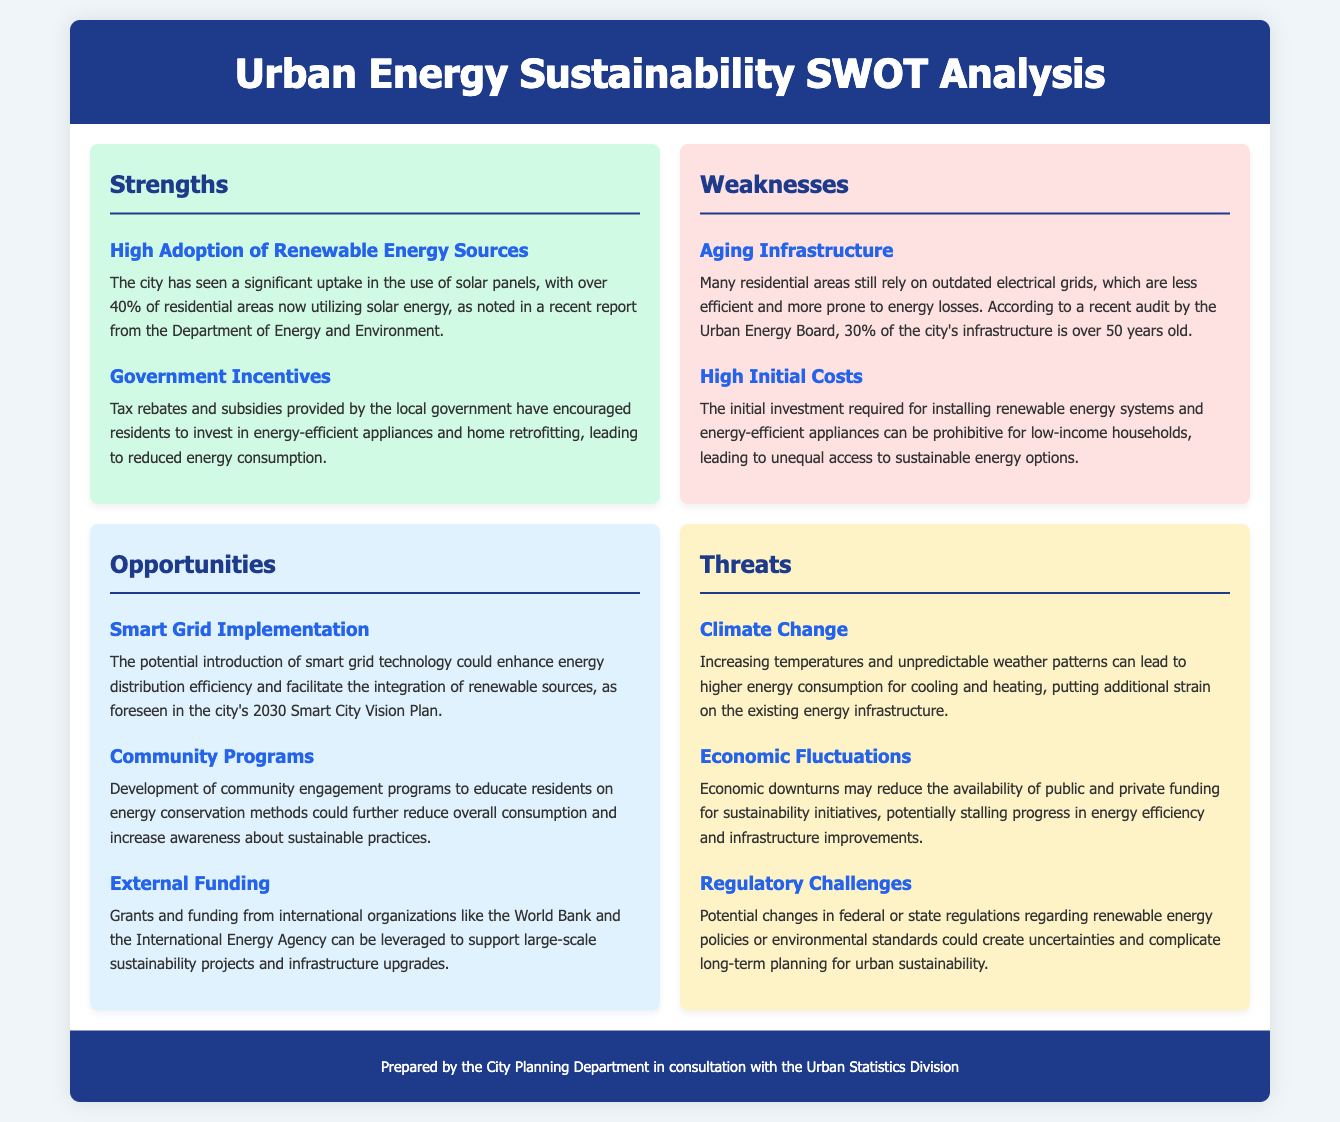What percentage of residential areas utilize solar energy? The document states that over 40% of residential areas now utilize solar energy.
Answer: over 40% What is a key factor contributing to the uptake of energy-efficient appliances? The local government's tax rebates and subsidies encourage investment in energy-efficient appliances, leading to reduced energy consumption.
Answer: Tax rebates and subsidies What is one weakness regarding the electrical infrastructure? According to a recent audit, 30% of the city's infrastructure is over 50 years old.
Answer: 30% What opportunity is foreseen in the city's 2030 Smart City Vision Plan? The potential introduction of smart grid technology is a noted opportunity in the 2030 Smart City Vision Plan.
Answer: Smart Grid Implementation Which organization could provide external funding for sustainability projects? Grants and funding can be leveraged from organizations like the World Bank.
Answer: World Bank How does climate change pose a threat to energy consumption? Increasing temperatures and unpredictable weather patterns can lead to higher energy consumption for cooling and heating.
Answer: Higher energy consumption What could stall progress in energy efficiency initiatives? Economic downturns may reduce the availability of public and private funding for sustainability initiatives, potentially stalling progress.
Answer: Economic downturns What is a potential regulatory challenge mentioned in the document? Potential changes in federal or state regulations regarding renewable energy policies or environmental standards could complicate long-term planning.
Answer: Regulatory challenges 